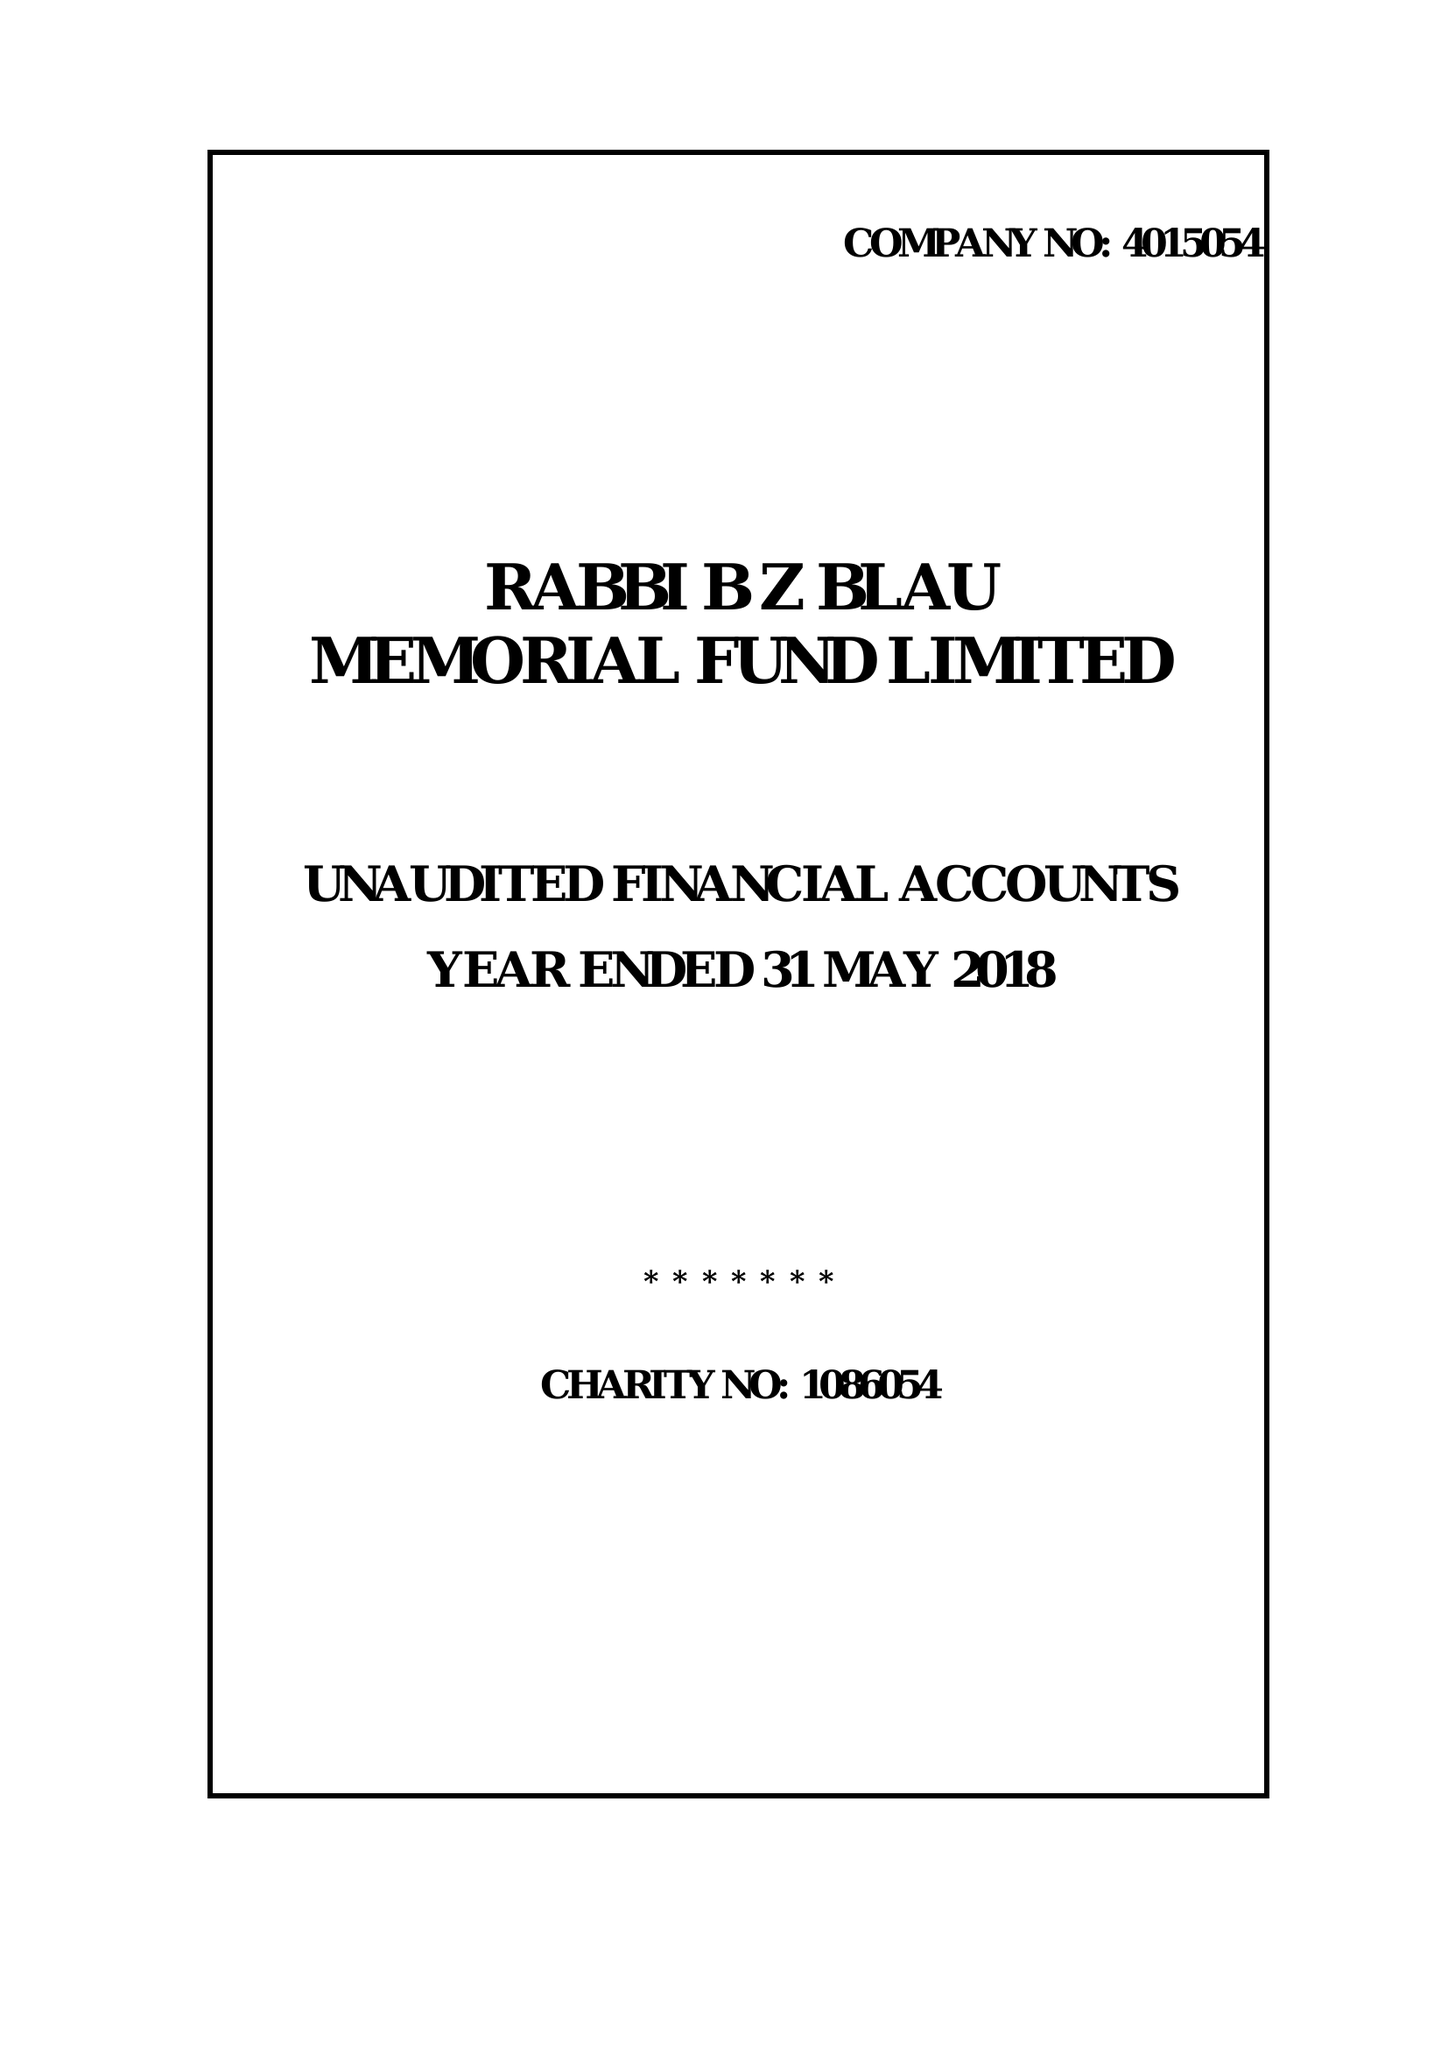What is the value for the address__postcode?
Answer the question using a single word or phrase. N16 0QQ 